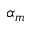<formula> <loc_0><loc_0><loc_500><loc_500>\alpha _ { m }</formula> 